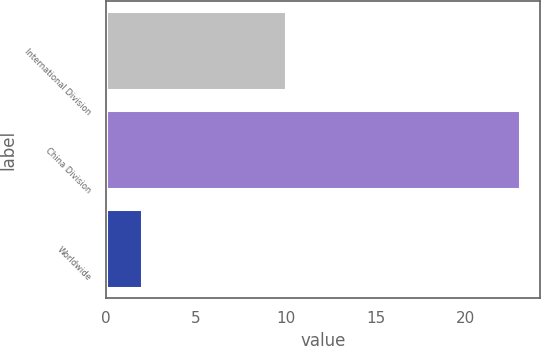Convert chart to OTSL. <chart><loc_0><loc_0><loc_500><loc_500><bar_chart><fcel>International Division<fcel>China Division<fcel>Worldwide<nl><fcel>10<fcel>23<fcel>2<nl></chart> 